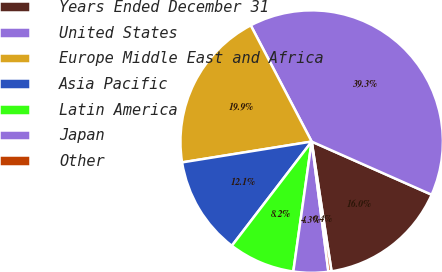<chart> <loc_0><loc_0><loc_500><loc_500><pie_chart><fcel>Years Ended December 31<fcel>United States<fcel>Europe Middle East and Africa<fcel>Asia Pacific<fcel>Latin America<fcel>Japan<fcel>Other<nl><fcel>15.95%<fcel>39.32%<fcel>19.85%<fcel>12.06%<fcel>8.17%<fcel>4.27%<fcel>0.38%<nl></chart> 